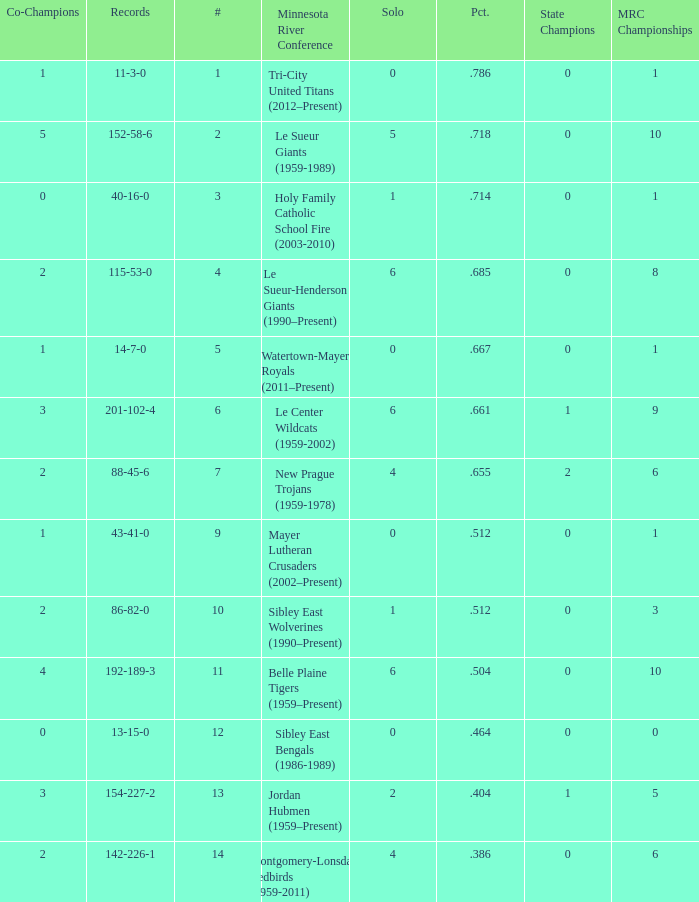What are the record(s) for the team with a winning percentage of .464? 13-15-0. Would you be able to parse every entry in this table? {'header': ['Co-Champions', 'Records', '#', 'Minnesota River Conference', 'Solo', 'Pct.', 'State Champions', 'MRC Championships'], 'rows': [['1', '11-3-0', '1', 'Tri-City United Titans (2012–Present)', '0', '.786', '0', '1'], ['5', '152-58-6', '2', 'Le Sueur Giants (1959-1989)', '5', '.718', '0', '10'], ['0', '40-16-0', '3', 'Holy Family Catholic School Fire (2003-2010)', '1', '.714', '0', '1'], ['2', '115-53-0', '4', 'Le Sueur-Henderson Giants (1990–Present)', '6', '.685', '0', '8'], ['1', '14-7-0', '5', 'Watertown-Mayer Royals (2011–Present)', '0', '.667', '0', '1'], ['3', '201-102-4', '6', 'Le Center Wildcats (1959-2002)', '6', '.661', '1', '9'], ['2', '88-45-6', '7', 'New Prague Trojans (1959-1978)', '4', '.655', '2', '6'], ['1', '43-41-0', '9', 'Mayer Lutheran Crusaders (2002–Present)', '0', '.512', '0', '1'], ['2', '86-82-0', '10', 'Sibley East Wolverines (1990–Present)', '1', '.512', '0', '3'], ['4', '192-189-3', '11', 'Belle Plaine Tigers (1959–Present)', '6', '.504', '0', '10'], ['0', '13-15-0', '12', 'Sibley East Bengals (1986-1989)', '0', '.464', '0', '0'], ['3', '154-227-2', '13', 'Jordan Hubmen (1959–Present)', '2', '.404', '1', '5'], ['2', '142-226-1', '14', 'Montgomery-Lonsdale Redbirds (1959-2011)', '4', '.386', '0', '6']]} 